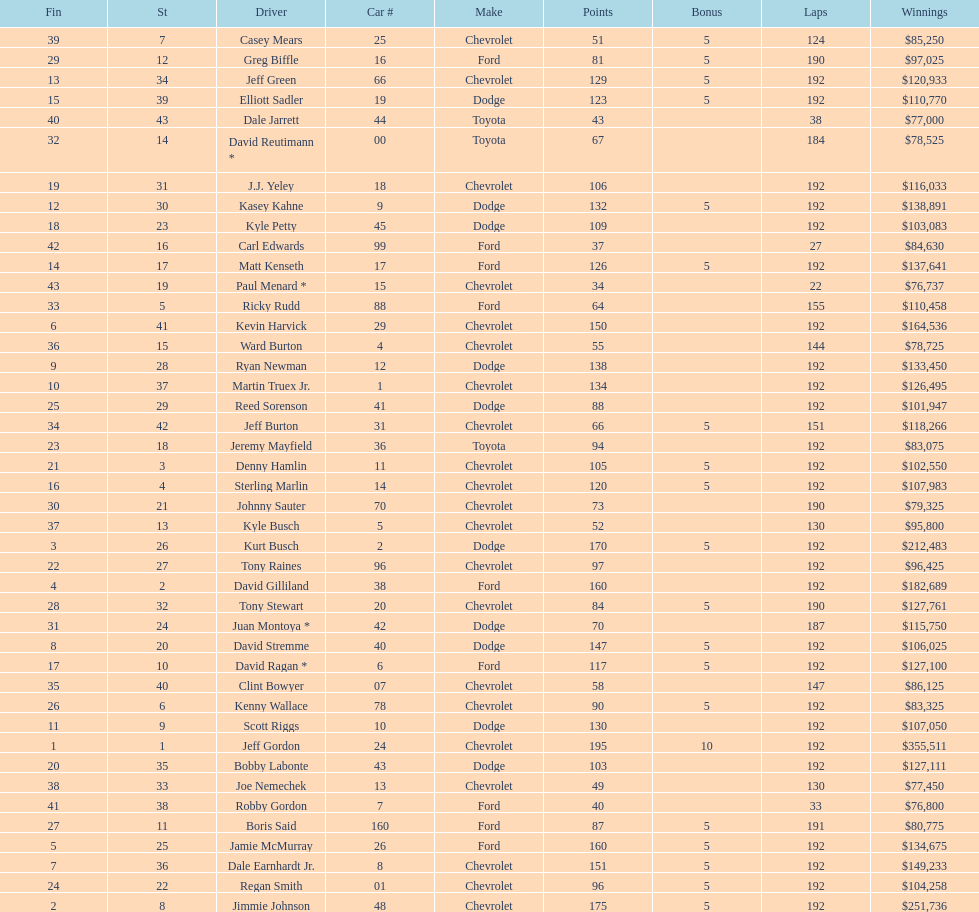How many drivers earned 5 bonus each in the race? 19. 